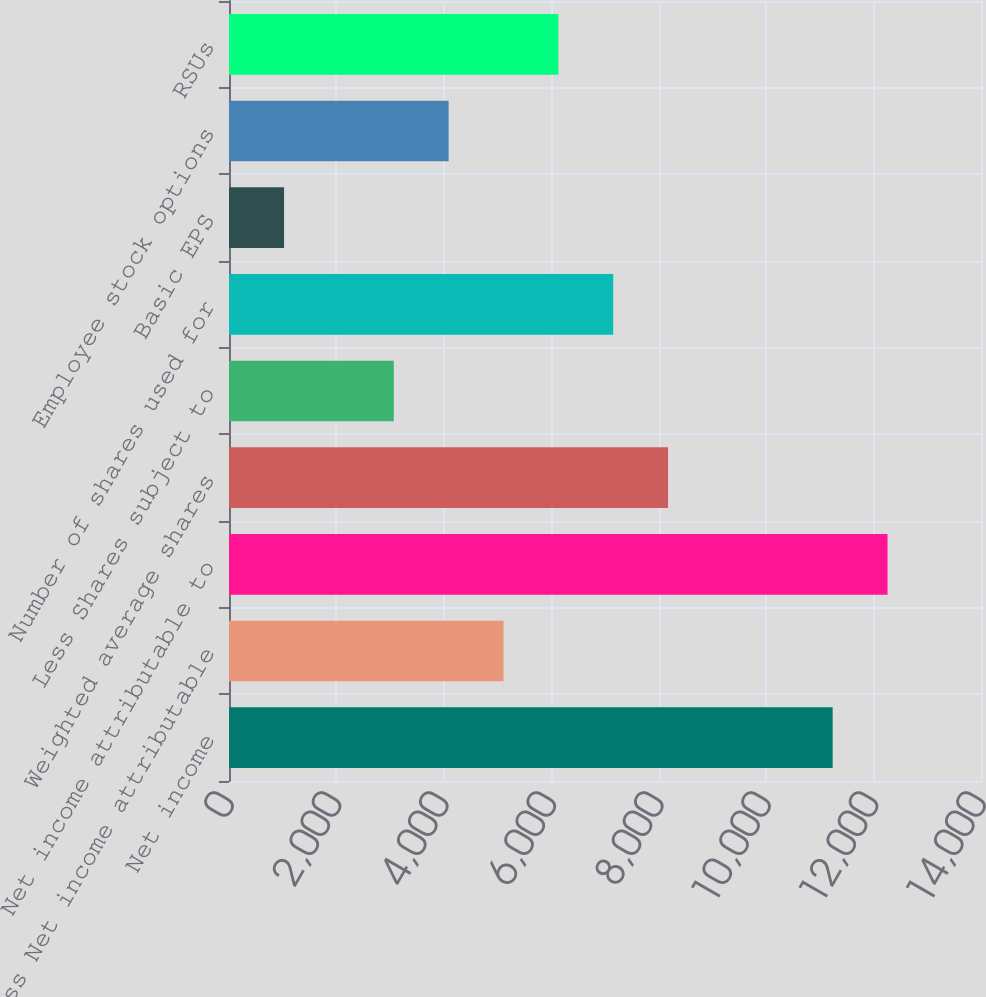Convert chart to OTSL. <chart><loc_0><loc_0><loc_500><loc_500><bar_chart><fcel>Net income<fcel>Less Net income attributable<fcel>Net income attributable to<fcel>Weighted average shares<fcel>Less Shares subject to<fcel>Number of shares used for<fcel>Basic EPS<fcel>Employee stock options<fcel>RSUs<nl><fcel>11238.3<fcel>5110.24<fcel>12259.7<fcel>8174.29<fcel>3067.54<fcel>7152.94<fcel>1024.84<fcel>4088.89<fcel>6131.59<nl></chart> 